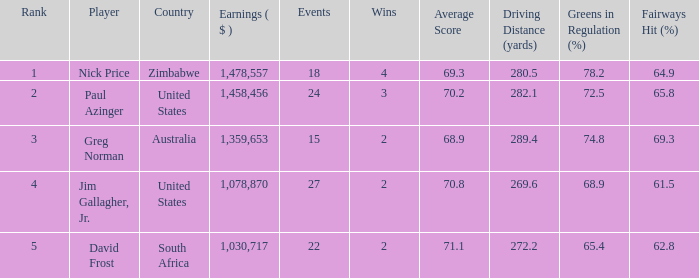How many events are in South Africa? 22.0. Write the full table. {'header': ['Rank', 'Player', 'Country', 'Earnings ( $ )', 'Events', 'Wins', 'Average Score', 'Driving Distance (yards)', 'Greens in Regulation (%)', 'Fairways Hit (%)'], 'rows': [['1', 'Nick Price', 'Zimbabwe', '1,478,557', '18', '4', '69.3', '280.5', '78.2', '64.9'], ['2', 'Paul Azinger', 'United States', '1,458,456', '24', '3', '70.2', '282.1', '72.5', '65.8'], ['3', 'Greg Norman', 'Australia', '1,359,653', '15', '2', '68.9', '289.4', '74.8', '69.3'], ['4', 'Jim Gallagher, Jr.', 'United States', '1,078,870', '27', '2', '70.8', '269.6', '68.9', '61.5'], ['5', 'David Frost', 'South Africa', '1,030,717', '22', '2', '71.1', '272.2', '65.4', '62.8']]} 